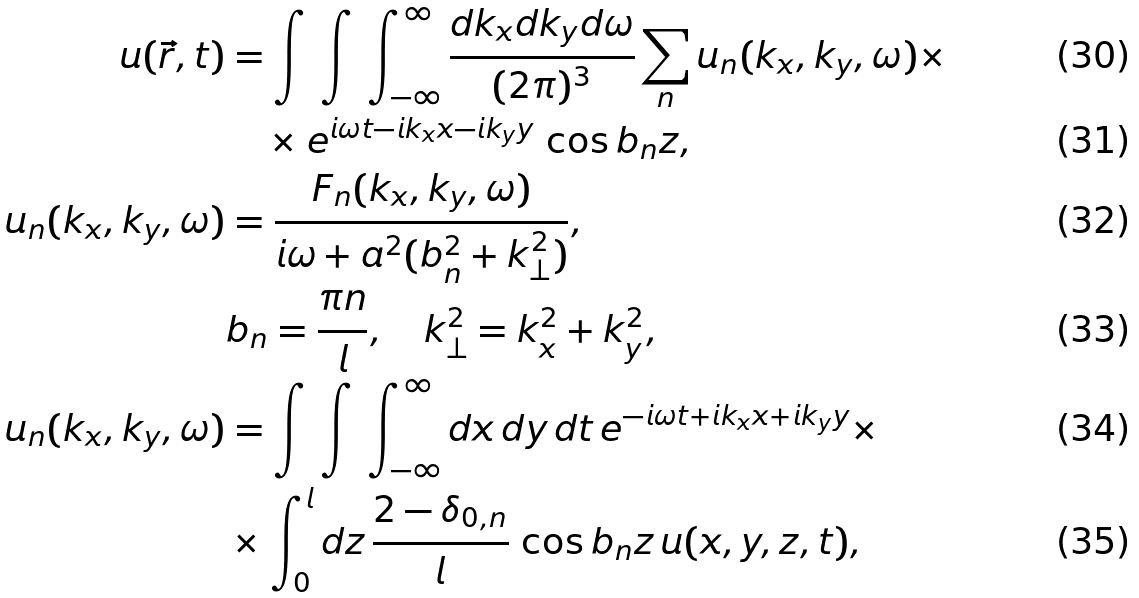Convert formula to latex. <formula><loc_0><loc_0><loc_500><loc_500>u ( \vec { r } , t ) & = \int \, \int \, \int _ { - \infty } ^ { \infty } \frac { d k _ { x } d k _ { y } d \omega } { ( 2 \pi ) ^ { 3 } } \sum _ { n } u _ { n } ( k _ { x } , k _ { y } , \omega ) \times \\ & \quad \times e ^ { i \omega t - i k _ { x } x - i k _ { y } y } \, \cos b _ { n } z , \\ u _ { n } ( k _ { x } , k _ { y } , \omega ) & = \frac { F _ { n } ( k _ { x } , k _ { y } , \omega ) } { i \omega + a ^ { 2 } ( b _ { n } ^ { 2 } + k _ { \bot } ^ { 2 } ) } , \\ & b _ { n } = \frac { \pi n } { l } , \quad k _ { \bot } ^ { 2 } = k _ { x } ^ { 2 } + k _ { y } ^ { 2 } , \\ u _ { n } ( k _ { x } , k _ { y } , \omega ) & = \int \, \int \, \int _ { - \infty } ^ { \infty } d x \, d y \, d t \, e ^ { - i \omega t + i k _ { x } x + i k _ { y } y } \times \\ & \times \int _ { 0 } ^ { l } d z \, \frac { 2 - \delta _ { 0 , n } } { l } \, \cos b _ { n } z \, u ( x , y , z , t ) ,</formula> 